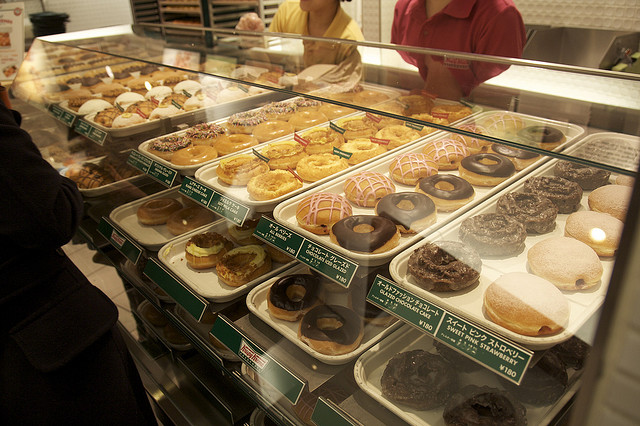Extract all visible text content from this image. SWEET PINK VI80 